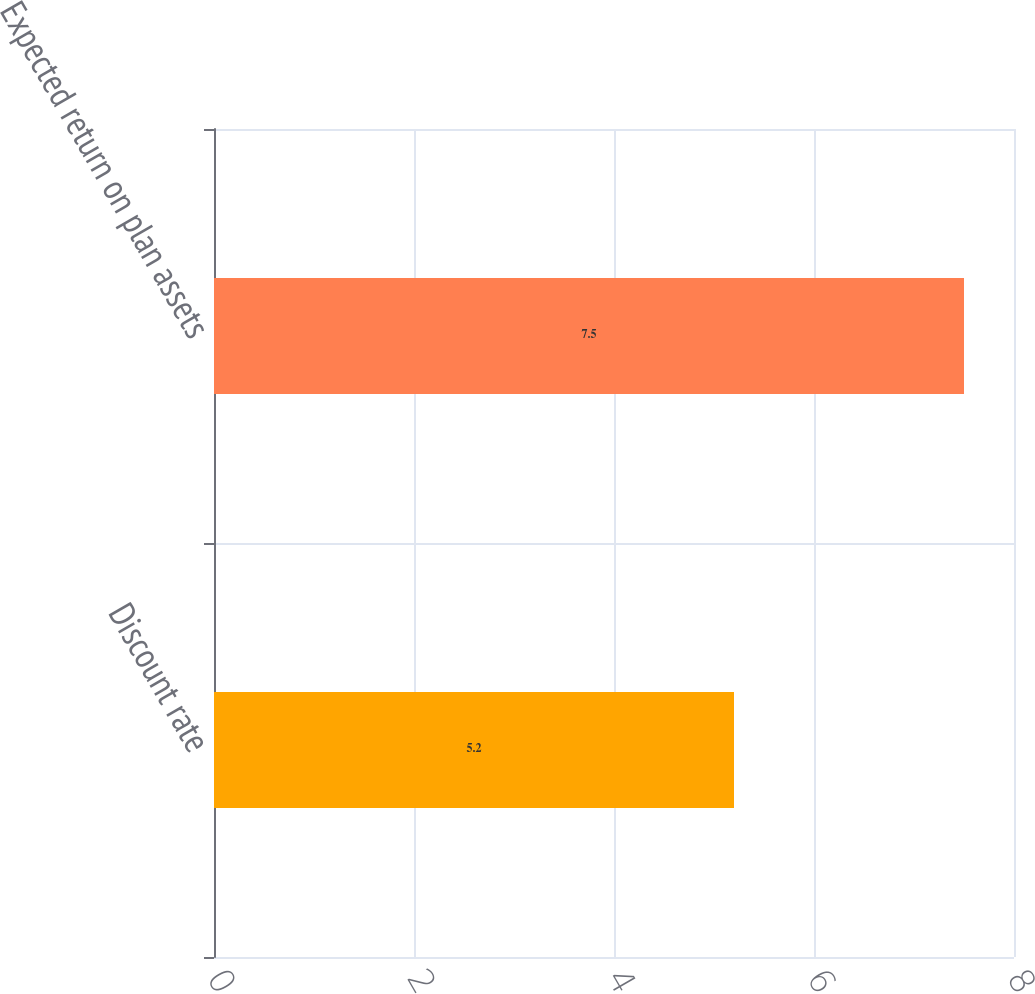Convert chart to OTSL. <chart><loc_0><loc_0><loc_500><loc_500><bar_chart><fcel>Discount rate<fcel>Expected return on plan assets<nl><fcel>5.2<fcel>7.5<nl></chart> 